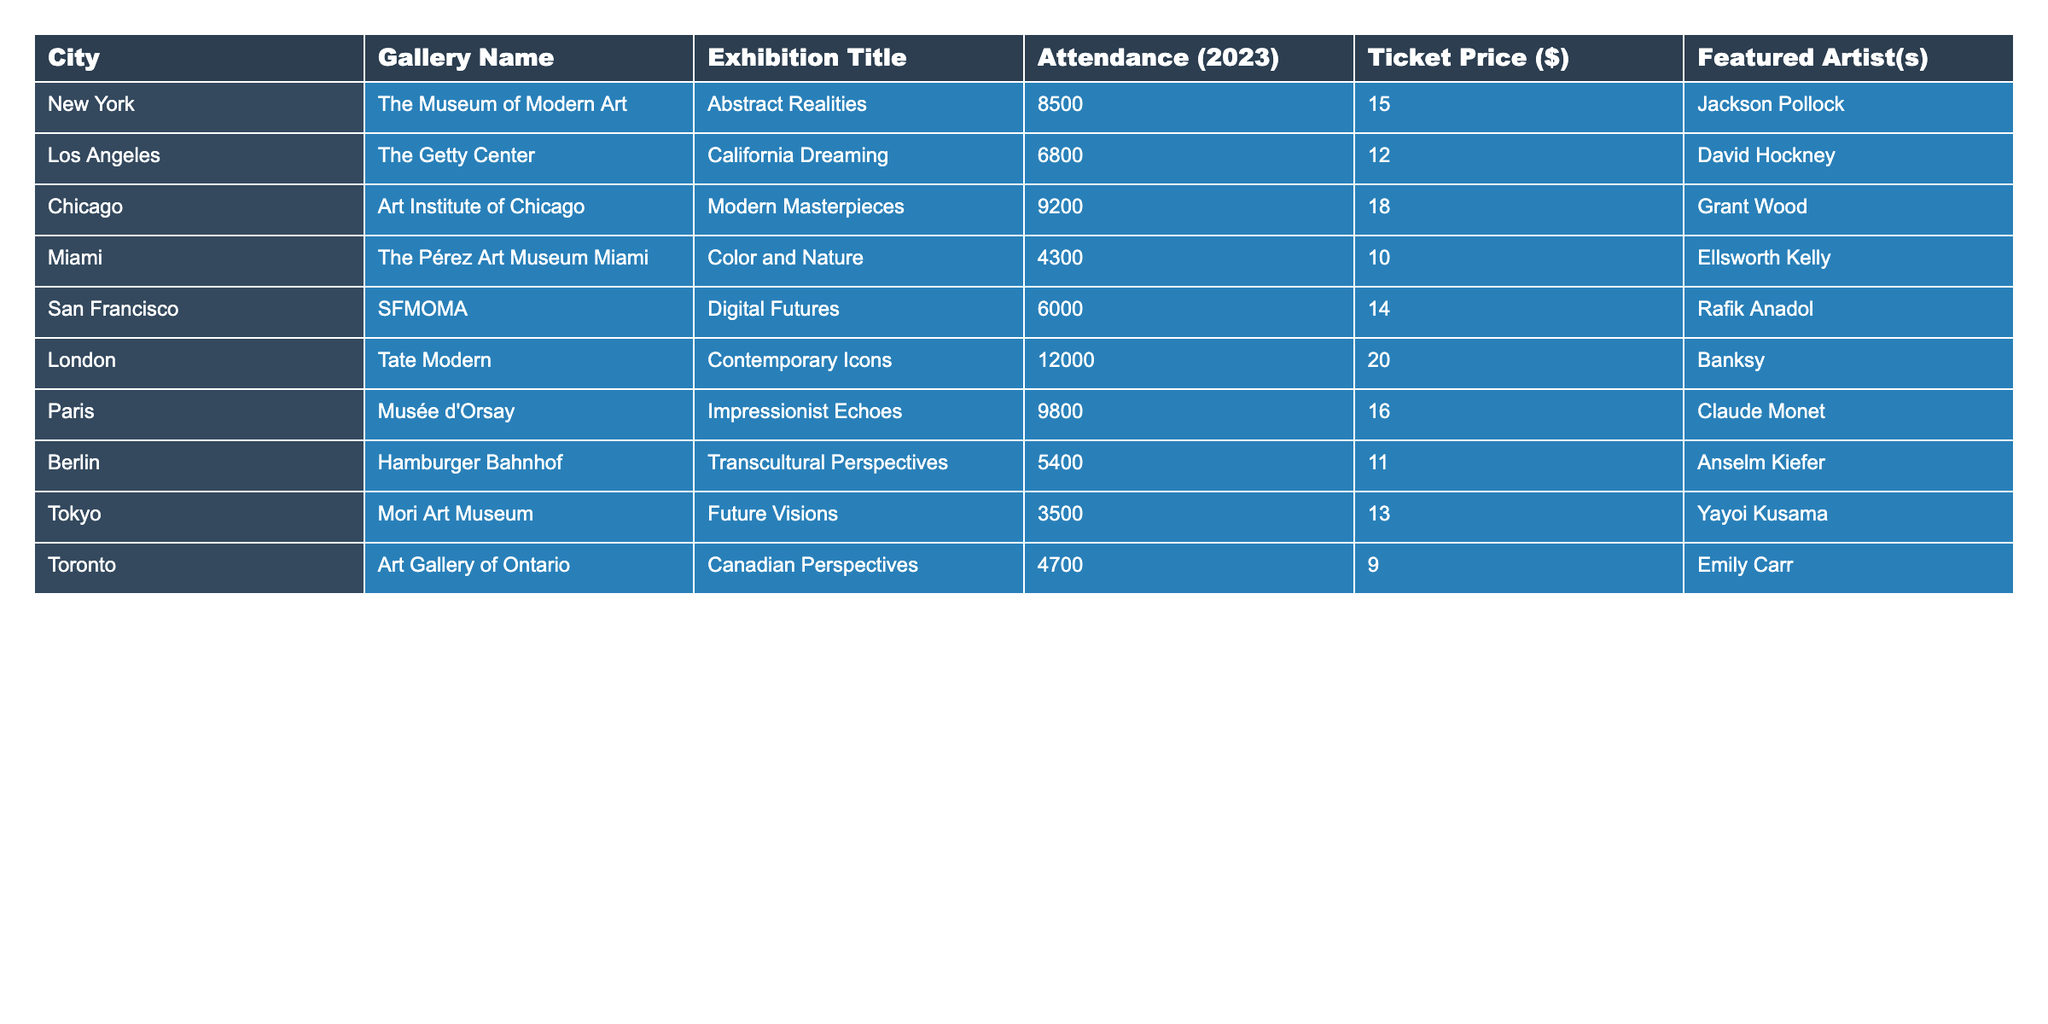What city had the highest exhibition attendance in 2023? By reviewing the attendance column in the table, London stands out with an attendance of 12,000, which is higher than any other city listed.
Answer: London What was the average ticket price across all the galleries listed? The ticket prices are: 15, 12, 18, 10, 14, 20, 16, 11, 13, and 9. Adding them gives 15 + 12 + 18 + 10 + 14 + 20 + 16 + 11 + 13 + 9 =  138. There are 10 prices, so the average ticket price is 138 / 10 = 13.8.
Answer: 13.8 Which gallery had the lowest attendance, and what was the ticket price? Checking the attendance figures, Miami’s Pérez Art Museum has the lowest attendance at 4,300, with a ticket price of $10.
Answer: The Pérez Art Museum, $10 Is the ticket price for the exhibition in Tokyo higher than the average ticket price? The ticket price in Tokyo is $13. The average ticket price calculated earlier is $13.8. Since $13 is less than $13.8, the answer is no.
Answer: No If we consider only the top three cities by attendance, what is the total attendance for those cities? The top three cities by attendance are London (12,000), Chicago (9,200), and Paris (9,800). Adding these together gives: 12,000 + 9,200 + 9,800 = 31,000.
Answer: 31,000 How many cities had an attendance greater than 5,000? By counting the attendance numbers above 5,000 in the table, we see they are New York, Los Angeles, Chicago, Paris, and London, totaling 5 cities.
Answer: 5 Which artist was featured in the exhibition with the second lowest attendance? The second lowest attendance is in Toronto with 4,700 visitors. The featured artist in the Art Gallery of Ontario is Emily Carr.
Answer: Emily Carr What is the difference in attendance between the highest and lowest exhibitions? The highest attendance is 12,000 in London and the lowest is 3,500 in Tokyo. The difference is 12,000 - 3,500 = 8,500.
Answer: 8,500 Can you confirm if any of the exhibitions had an attendance of over 9,000? Looking at the attendance column, London (12,000), Chicago (9,200), and Paris (9,800) all have attendance figures over 9,000. Thus, the answer is yes.
Answer: Yes Which gallery features Grant Wood and what was its attendance? The Art Institute of Chicago features Grant Wood, and its attendance is 9,200 based on the information in the table.
Answer: Art Institute of Chicago, 9,200 